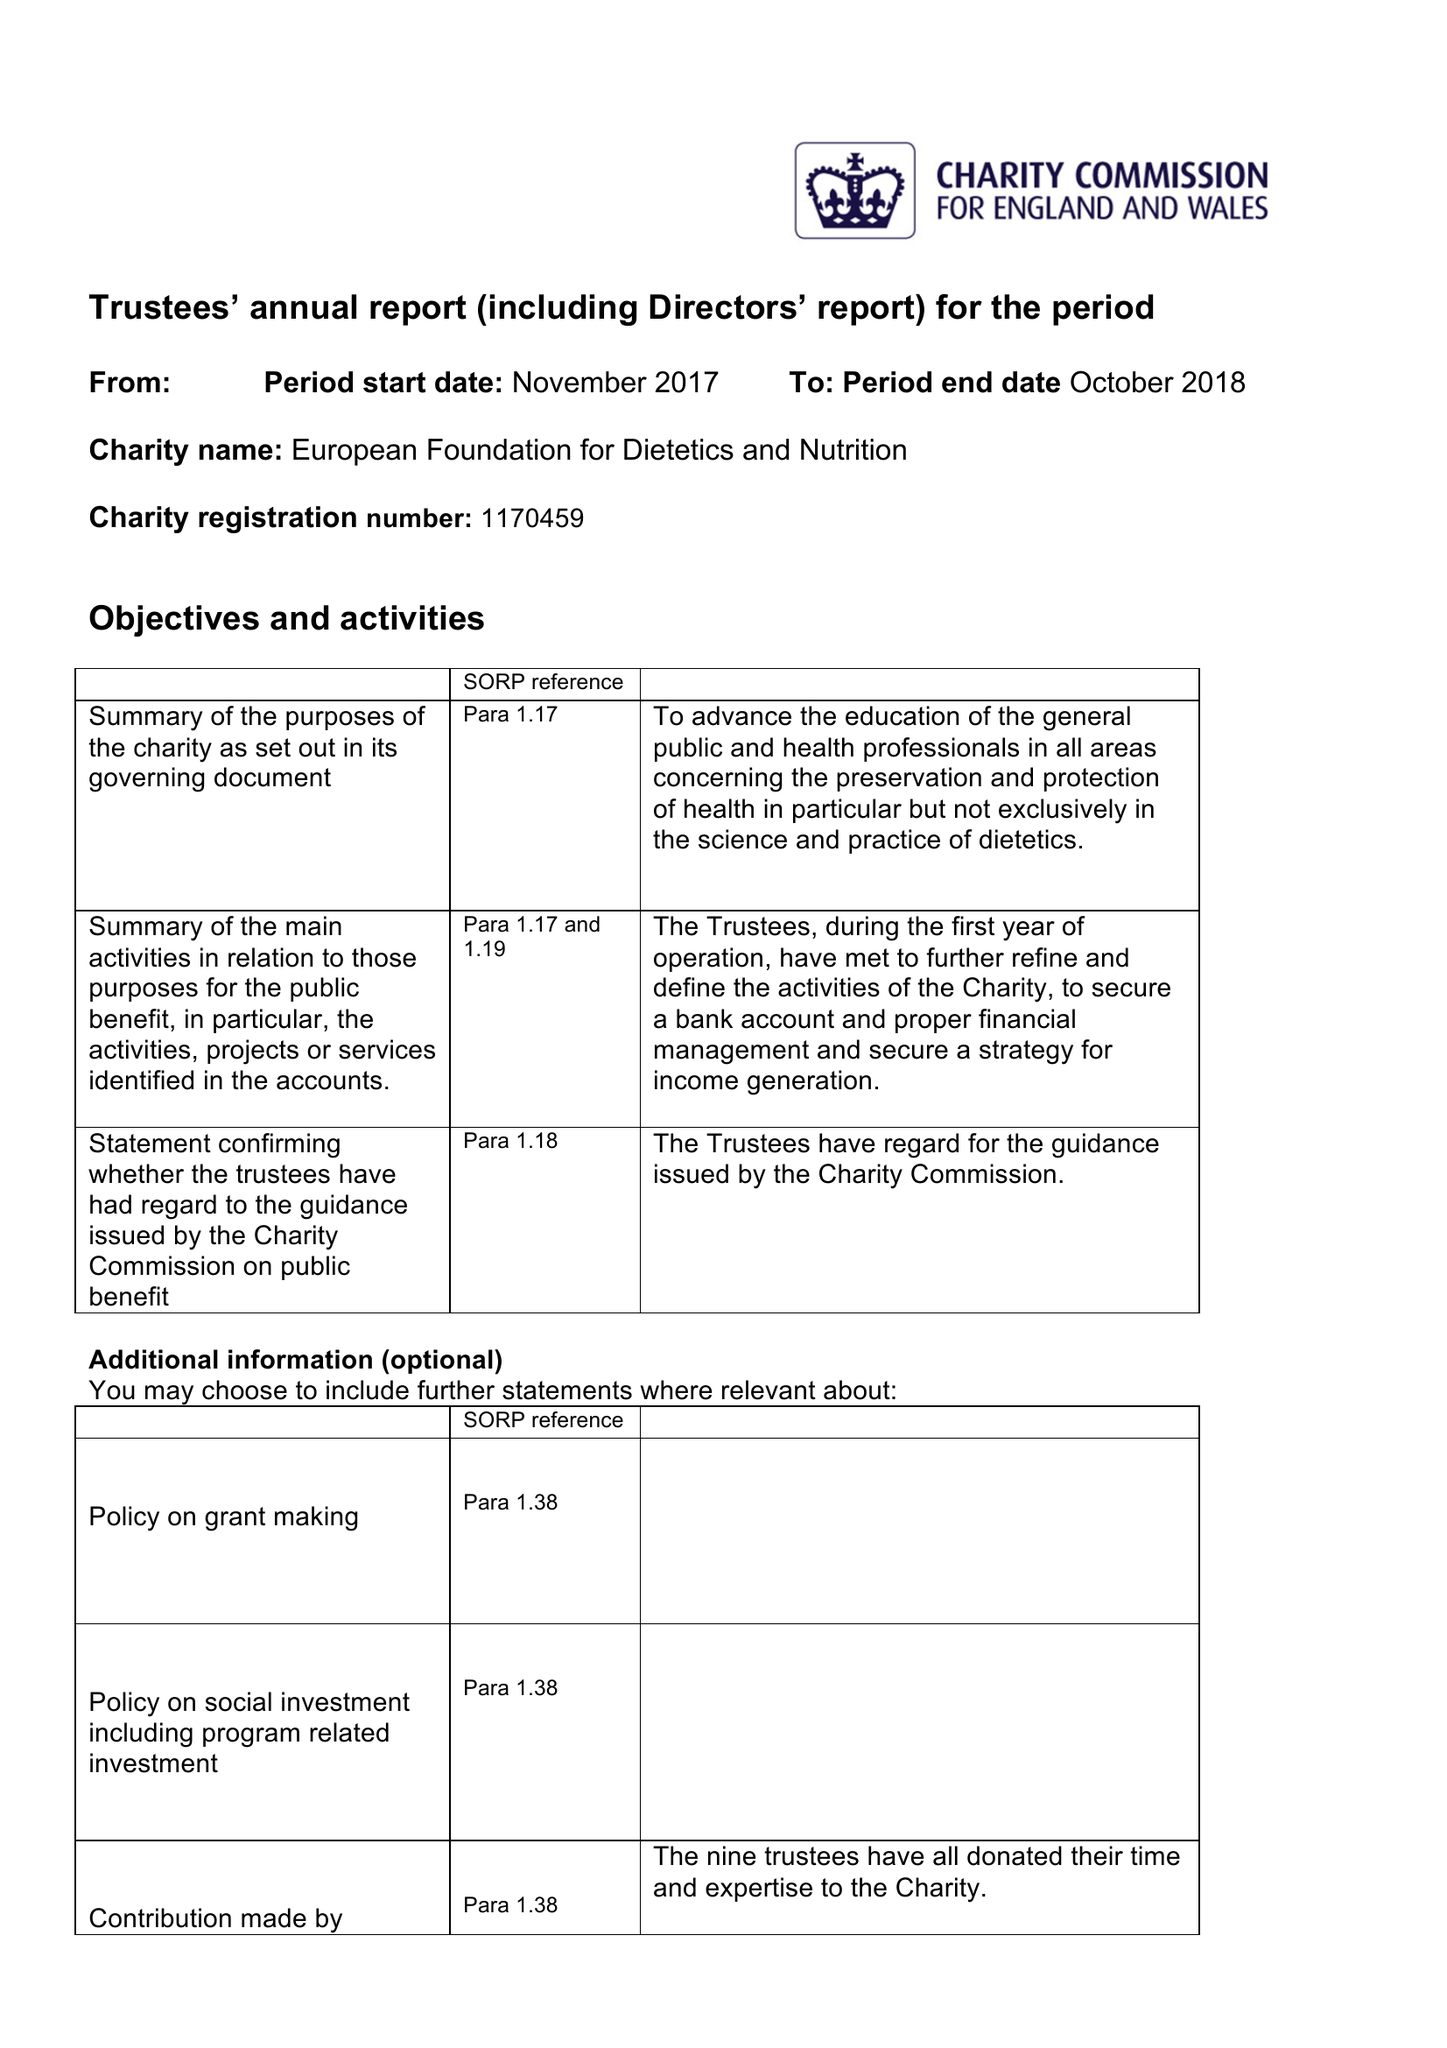What is the value for the charity_name?
Answer the question using a single word or phrase. European Foundation For Dietetics and Nutrition 